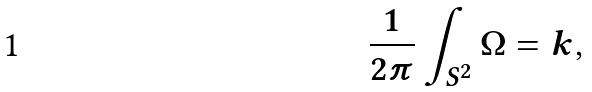<formula> <loc_0><loc_0><loc_500><loc_500>\frac { 1 } { 2 \pi } \int _ { S ^ { 2 } } \Omega = k ,</formula> 